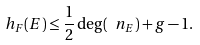Convert formula to latex. <formula><loc_0><loc_0><loc_500><loc_500>h _ { F } ( E ) \leq \frac { 1 } { 2 } \deg ( \ n _ { E } ) + g - 1 .</formula> 